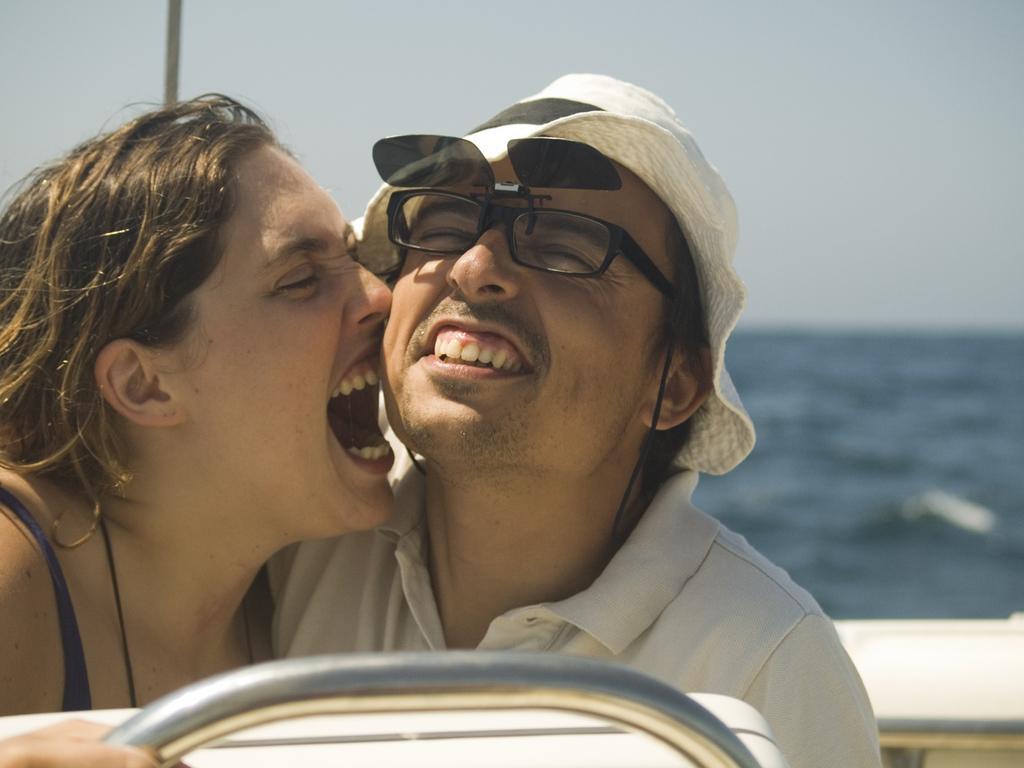Can you describe this image briefly? In this picture we can see a man and a woman sitting in a boat, in the background we can see water, there is the sky at the top of the picture. 